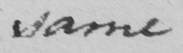Please provide the text content of this handwritten line. same 